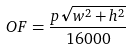Convert formula to latex. <formula><loc_0><loc_0><loc_500><loc_500>O F = \frac { p \sqrt { w ^ { 2 } + h ^ { 2 } } } { 1 6 0 0 0 }</formula> 